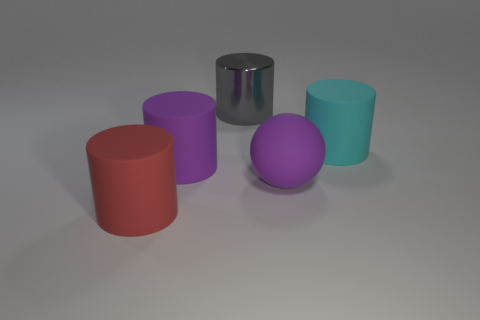Subtract all big cyan cylinders. How many cylinders are left? 3 Subtract all gray cylinders. How many cylinders are left? 3 Add 4 purple cubes. How many objects exist? 9 Subtract all cylinders. How many objects are left? 1 Subtract 0 brown spheres. How many objects are left? 5 Subtract 1 spheres. How many spheres are left? 0 Subtract all green cylinders. Subtract all gray blocks. How many cylinders are left? 4 Subtract all cyan balls. How many red cylinders are left? 1 Subtract all gray shiny things. Subtract all large cyan matte things. How many objects are left? 3 Add 3 big gray metal objects. How many big gray metal objects are left? 4 